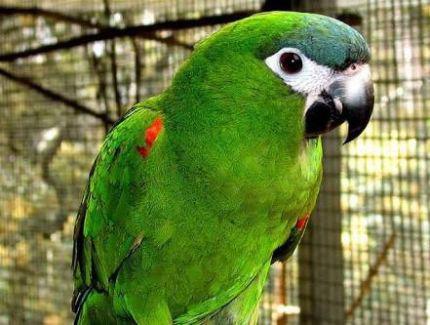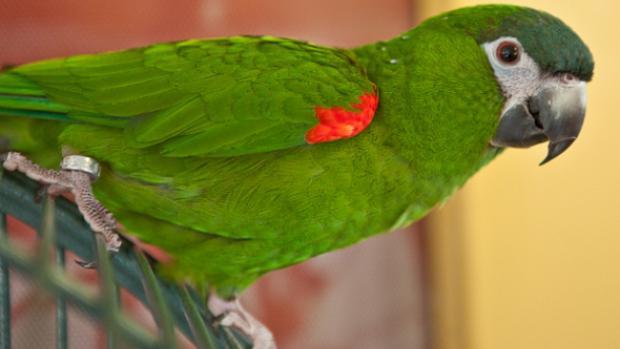The first image is the image on the left, the second image is the image on the right. For the images shown, is this caption "An image contains one right-facing parrot in front of a mesh." true? Answer yes or no. Yes. The first image is the image on the left, the second image is the image on the right. For the images displayed, is the sentence "There are two parrots in total, both with predominantly green feathers." factually correct? Answer yes or no. Yes. 